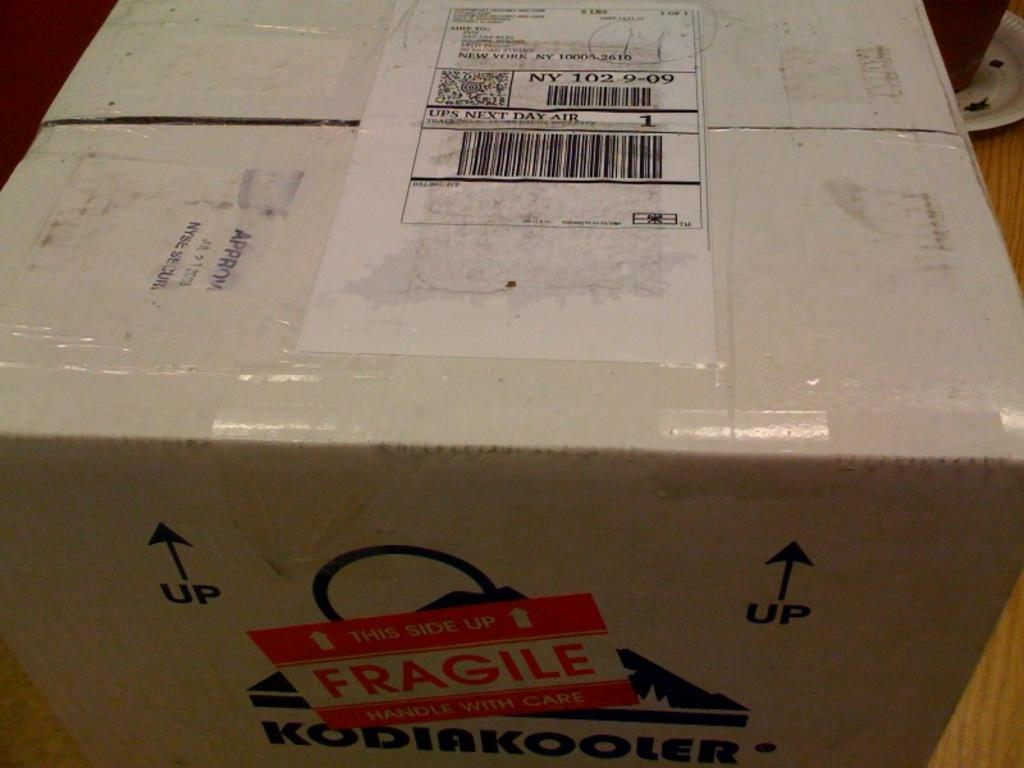Provide a one-sentence caption for the provided image. A package has a UPS Next Day Air sticker on the top. 